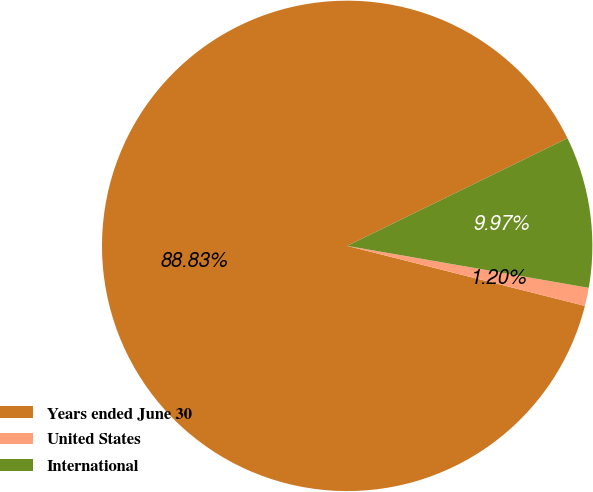Convert chart. <chart><loc_0><loc_0><loc_500><loc_500><pie_chart><fcel>Years ended June 30<fcel>United States<fcel>International<nl><fcel>88.83%<fcel>1.2%<fcel>9.97%<nl></chart> 